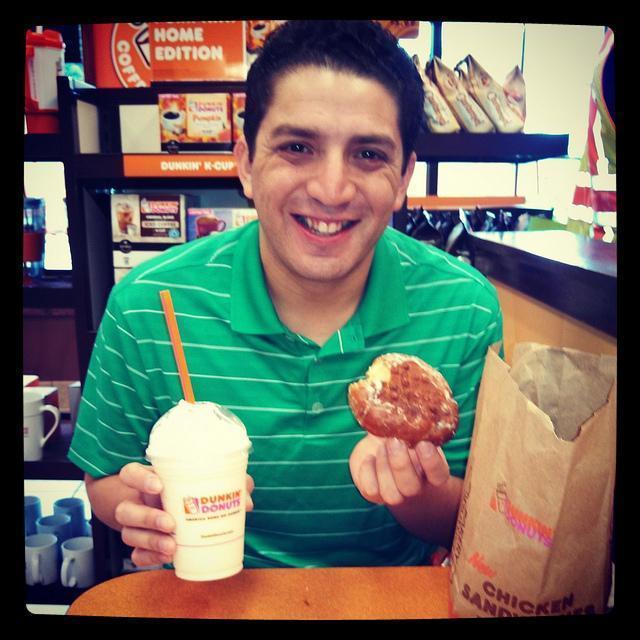How many cups are visible?
Give a very brief answer. 2. How many apple brand laptops can you see?
Give a very brief answer. 0. 